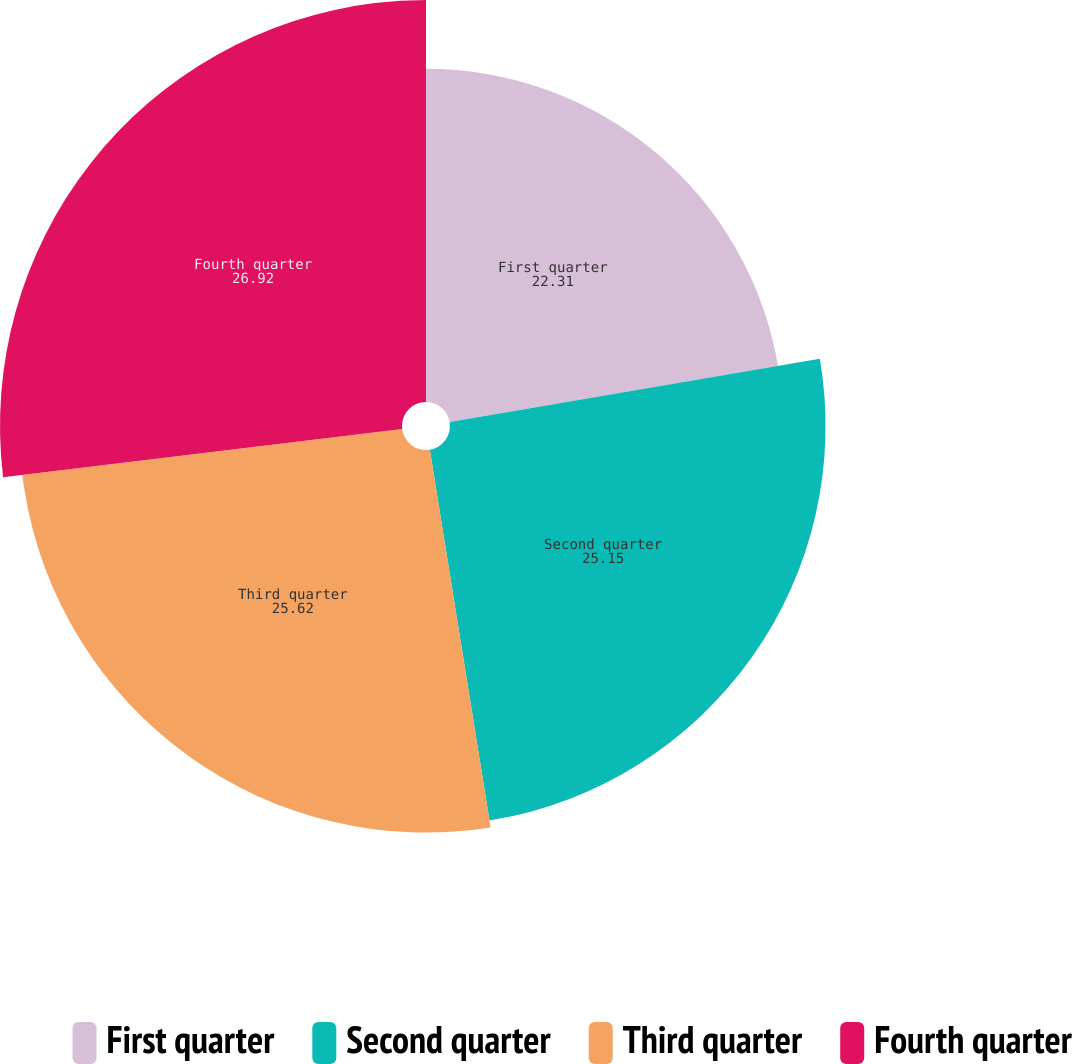Convert chart. <chart><loc_0><loc_0><loc_500><loc_500><pie_chart><fcel>First quarter<fcel>Second quarter<fcel>Third quarter<fcel>Fourth quarter<nl><fcel>22.31%<fcel>25.15%<fcel>25.62%<fcel>26.92%<nl></chart> 